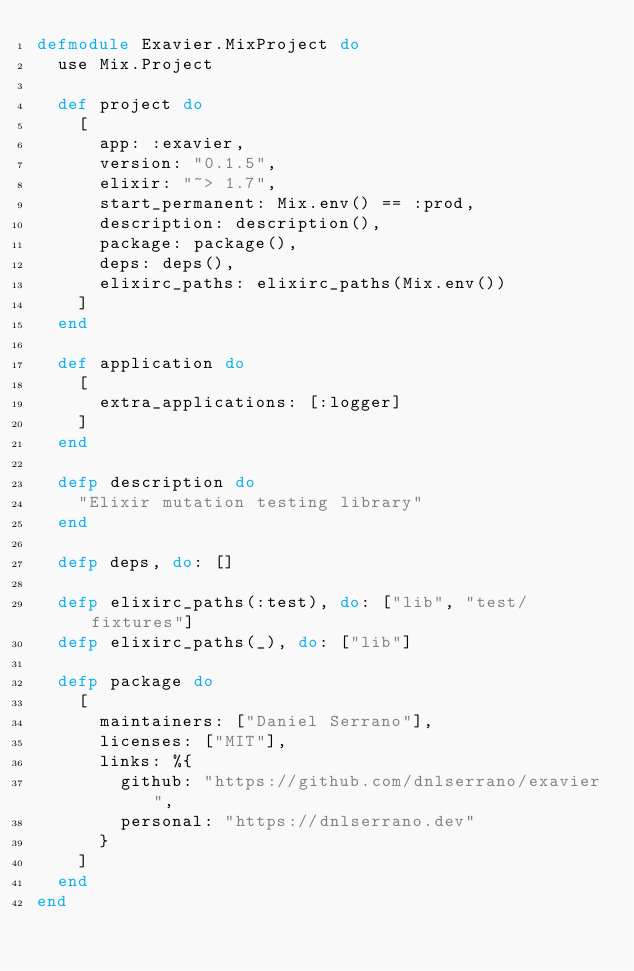<code> <loc_0><loc_0><loc_500><loc_500><_Elixir_>defmodule Exavier.MixProject do
  use Mix.Project

  def project do
    [
      app: :exavier,
      version: "0.1.5",
      elixir: "~> 1.7",
      start_permanent: Mix.env() == :prod,
      description: description(),
      package: package(),
      deps: deps(),
      elixirc_paths: elixirc_paths(Mix.env())
    ]
  end

  def application do
    [
      extra_applications: [:logger]
    ]
  end

  defp description do
    "Elixir mutation testing library"
  end

  defp deps, do: []

  defp elixirc_paths(:test), do: ["lib", "test/fixtures"]
  defp elixirc_paths(_), do: ["lib"]

  defp package do
    [
      maintainers: ["Daniel Serrano"],
      licenses: ["MIT"],
      links: %{
        github: "https://github.com/dnlserrano/exavier",
        personal: "https://dnlserrano.dev"
      }
    ]
  end
end
</code> 